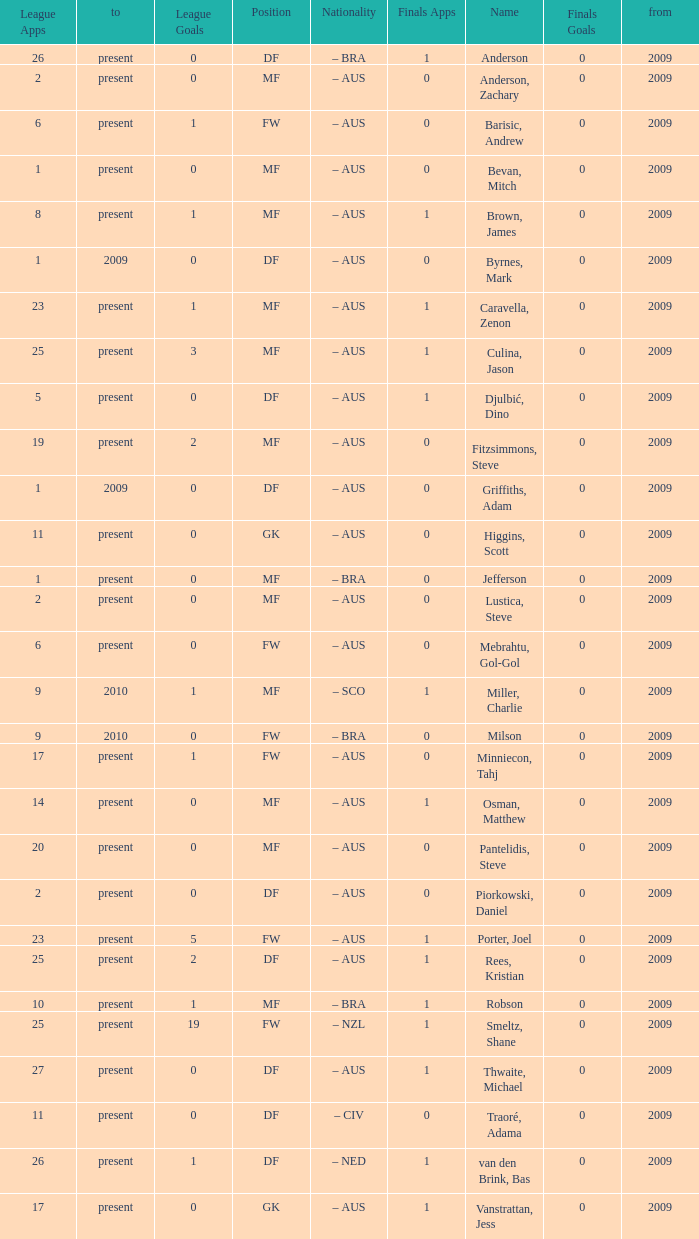Name the to for 19 league apps Present. 